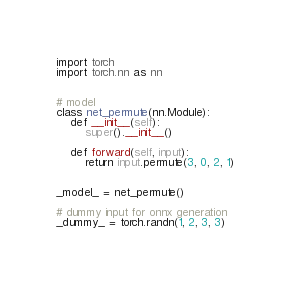<code> <loc_0><loc_0><loc_500><loc_500><_Python_>import torch
import torch.nn as nn


# model
class net_permute(nn.Module):
    def __init__(self):
        super().__init__()

    def forward(self, input):
        return input.permute(3, 0, 2, 1)


_model_ = net_permute()

# dummy input for onnx generation
_dummy_ = torch.randn(1, 2, 3, 3)
</code> 